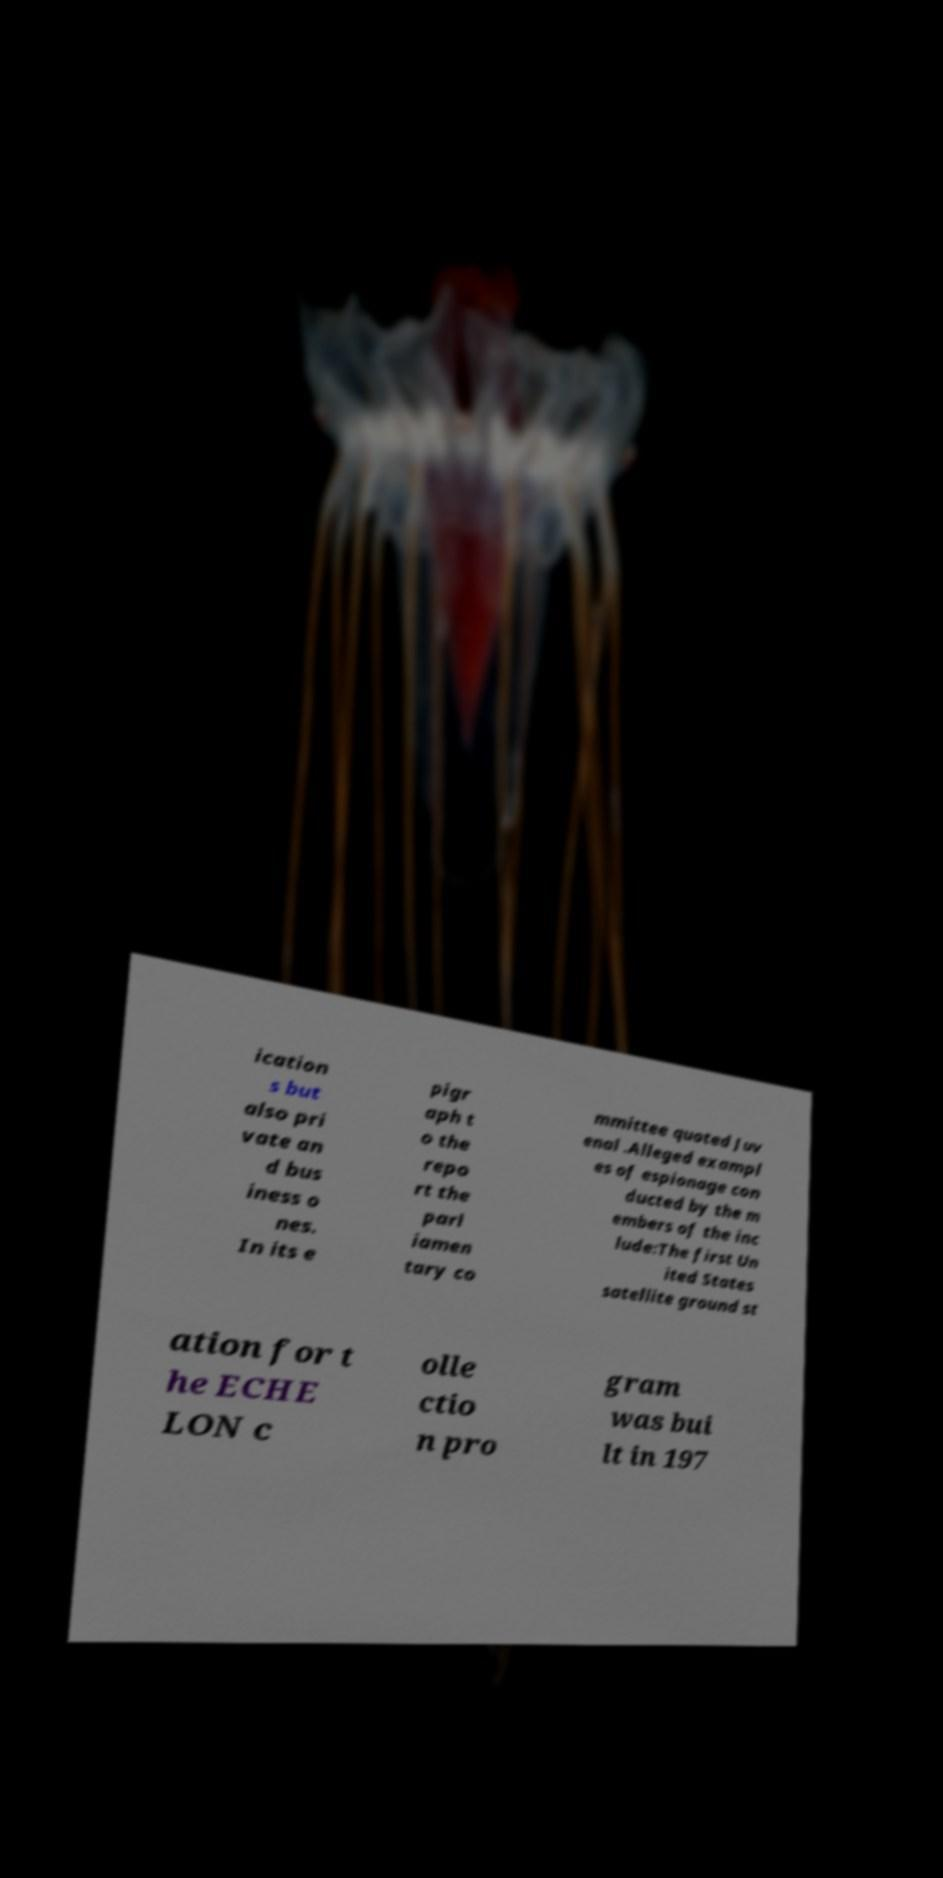Please identify and transcribe the text found in this image. ication s but also pri vate an d bus iness o nes. In its e pigr aph t o the repo rt the parl iamen tary co mmittee quoted Juv enal .Alleged exampl es of espionage con ducted by the m embers of the inc lude:The first Un ited States satellite ground st ation for t he ECHE LON c olle ctio n pro gram was bui lt in 197 